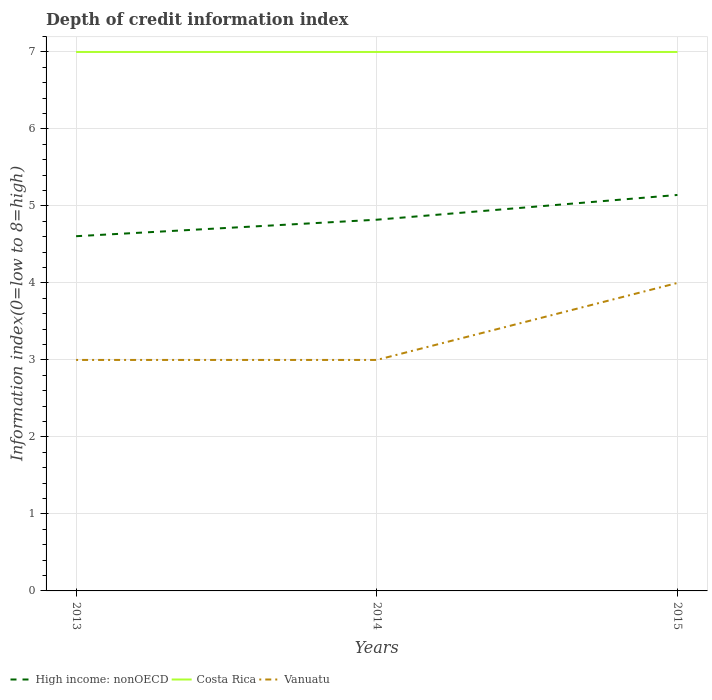Is the number of lines equal to the number of legend labels?
Your answer should be compact. Yes. Across all years, what is the maximum information index in High income: nonOECD?
Offer a very short reply. 4.61. What is the total information index in Vanuatu in the graph?
Your answer should be very brief. -1. What is the difference between the highest and the second highest information index in Costa Rica?
Offer a terse response. 0. Is the information index in High income: nonOECD strictly greater than the information index in Vanuatu over the years?
Make the answer very short. No. How many years are there in the graph?
Your answer should be compact. 3. Where does the legend appear in the graph?
Make the answer very short. Bottom left. How many legend labels are there?
Provide a short and direct response. 3. How are the legend labels stacked?
Your answer should be very brief. Horizontal. What is the title of the graph?
Your response must be concise. Depth of credit information index. Does "Equatorial Guinea" appear as one of the legend labels in the graph?
Your response must be concise. No. What is the label or title of the X-axis?
Your answer should be very brief. Years. What is the label or title of the Y-axis?
Your answer should be compact. Information index(0=low to 8=high). What is the Information index(0=low to 8=high) of High income: nonOECD in 2013?
Make the answer very short. 4.61. What is the Information index(0=low to 8=high) in High income: nonOECD in 2014?
Ensure brevity in your answer.  4.82. What is the Information index(0=low to 8=high) in Costa Rica in 2014?
Your answer should be very brief. 7. What is the Information index(0=low to 8=high) of High income: nonOECD in 2015?
Your answer should be compact. 5.14. What is the Information index(0=low to 8=high) of Costa Rica in 2015?
Make the answer very short. 7. Across all years, what is the maximum Information index(0=low to 8=high) of High income: nonOECD?
Keep it short and to the point. 5.14. Across all years, what is the maximum Information index(0=low to 8=high) in Costa Rica?
Provide a succinct answer. 7. Across all years, what is the minimum Information index(0=low to 8=high) of High income: nonOECD?
Your response must be concise. 4.61. What is the total Information index(0=low to 8=high) in High income: nonOECD in the graph?
Provide a succinct answer. 14.57. What is the difference between the Information index(0=low to 8=high) of High income: nonOECD in 2013 and that in 2014?
Make the answer very short. -0.21. What is the difference between the Information index(0=low to 8=high) of Costa Rica in 2013 and that in 2014?
Your response must be concise. 0. What is the difference between the Information index(0=low to 8=high) in Vanuatu in 2013 and that in 2014?
Your answer should be very brief. 0. What is the difference between the Information index(0=low to 8=high) of High income: nonOECD in 2013 and that in 2015?
Your answer should be compact. -0.54. What is the difference between the Information index(0=low to 8=high) of Vanuatu in 2013 and that in 2015?
Keep it short and to the point. -1. What is the difference between the Information index(0=low to 8=high) of High income: nonOECD in 2014 and that in 2015?
Provide a short and direct response. -0.32. What is the difference between the Information index(0=low to 8=high) of Costa Rica in 2014 and that in 2015?
Provide a succinct answer. 0. What is the difference between the Information index(0=low to 8=high) of Vanuatu in 2014 and that in 2015?
Make the answer very short. -1. What is the difference between the Information index(0=low to 8=high) of High income: nonOECD in 2013 and the Information index(0=low to 8=high) of Costa Rica in 2014?
Provide a short and direct response. -2.39. What is the difference between the Information index(0=low to 8=high) of High income: nonOECD in 2013 and the Information index(0=low to 8=high) of Vanuatu in 2014?
Keep it short and to the point. 1.61. What is the difference between the Information index(0=low to 8=high) of High income: nonOECD in 2013 and the Information index(0=low to 8=high) of Costa Rica in 2015?
Your response must be concise. -2.39. What is the difference between the Information index(0=low to 8=high) in High income: nonOECD in 2013 and the Information index(0=low to 8=high) in Vanuatu in 2015?
Your answer should be very brief. 0.61. What is the difference between the Information index(0=low to 8=high) of High income: nonOECD in 2014 and the Information index(0=low to 8=high) of Costa Rica in 2015?
Provide a short and direct response. -2.18. What is the difference between the Information index(0=low to 8=high) in High income: nonOECD in 2014 and the Information index(0=low to 8=high) in Vanuatu in 2015?
Your response must be concise. 0.82. What is the average Information index(0=low to 8=high) in High income: nonOECD per year?
Provide a short and direct response. 4.86. What is the average Information index(0=low to 8=high) in Costa Rica per year?
Make the answer very short. 7. What is the average Information index(0=low to 8=high) in Vanuatu per year?
Give a very brief answer. 3.33. In the year 2013, what is the difference between the Information index(0=low to 8=high) of High income: nonOECD and Information index(0=low to 8=high) of Costa Rica?
Your answer should be compact. -2.39. In the year 2013, what is the difference between the Information index(0=low to 8=high) in High income: nonOECD and Information index(0=low to 8=high) in Vanuatu?
Your answer should be very brief. 1.61. In the year 2014, what is the difference between the Information index(0=low to 8=high) in High income: nonOECD and Information index(0=low to 8=high) in Costa Rica?
Your answer should be very brief. -2.18. In the year 2014, what is the difference between the Information index(0=low to 8=high) of High income: nonOECD and Information index(0=low to 8=high) of Vanuatu?
Offer a very short reply. 1.82. In the year 2014, what is the difference between the Information index(0=low to 8=high) of Costa Rica and Information index(0=low to 8=high) of Vanuatu?
Provide a short and direct response. 4. In the year 2015, what is the difference between the Information index(0=low to 8=high) of High income: nonOECD and Information index(0=low to 8=high) of Costa Rica?
Offer a very short reply. -1.86. In the year 2015, what is the difference between the Information index(0=low to 8=high) in High income: nonOECD and Information index(0=low to 8=high) in Vanuatu?
Keep it short and to the point. 1.14. What is the ratio of the Information index(0=low to 8=high) in High income: nonOECD in 2013 to that in 2014?
Your response must be concise. 0.96. What is the ratio of the Information index(0=low to 8=high) of Costa Rica in 2013 to that in 2014?
Provide a succinct answer. 1. What is the ratio of the Information index(0=low to 8=high) in Vanuatu in 2013 to that in 2014?
Provide a succinct answer. 1. What is the ratio of the Information index(0=low to 8=high) of High income: nonOECD in 2013 to that in 2015?
Your answer should be very brief. 0.9. What is the ratio of the Information index(0=low to 8=high) in Vanuatu in 2013 to that in 2015?
Your answer should be compact. 0.75. What is the difference between the highest and the second highest Information index(0=low to 8=high) in High income: nonOECD?
Give a very brief answer. 0.32. What is the difference between the highest and the second highest Information index(0=low to 8=high) of Costa Rica?
Make the answer very short. 0. What is the difference between the highest and the second highest Information index(0=low to 8=high) in Vanuatu?
Your response must be concise. 1. What is the difference between the highest and the lowest Information index(0=low to 8=high) in High income: nonOECD?
Your answer should be very brief. 0.54. What is the difference between the highest and the lowest Information index(0=low to 8=high) of Costa Rica?
Make the answer very short. 0. 